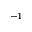Convert formula to latex. <formula><loc_0><loc_0><loc_500><loc_500>^ { - 1 }</formula> 